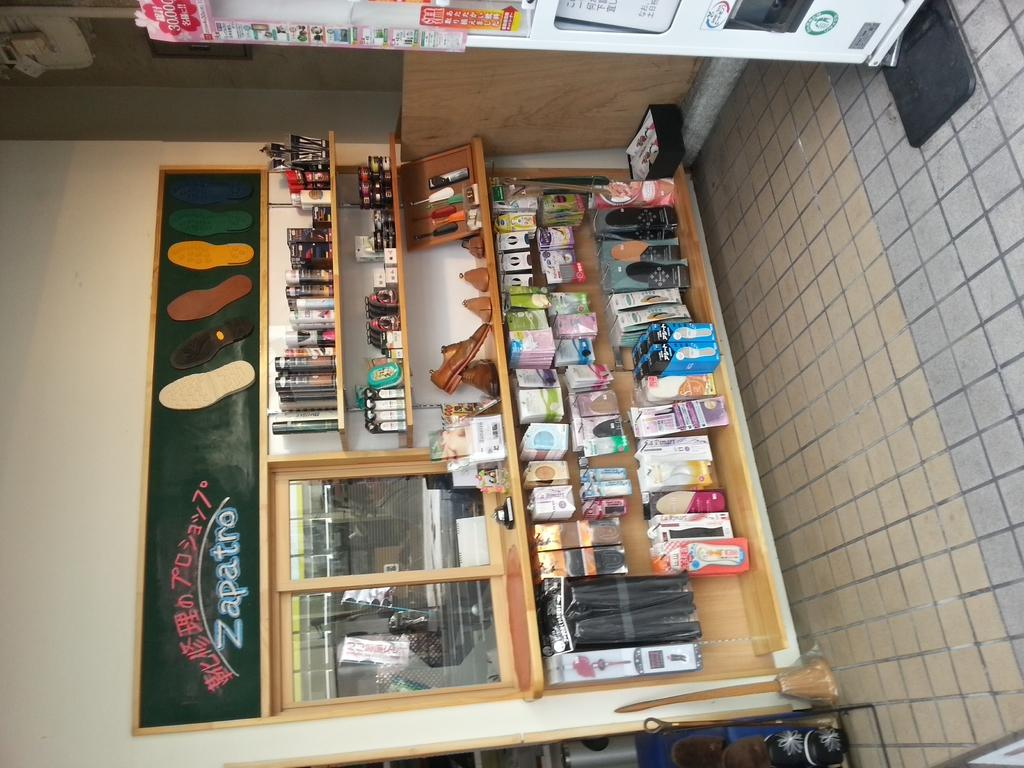<image>
Provide a brief description of the given image. A vendor stand called Zapatro sells many things. 